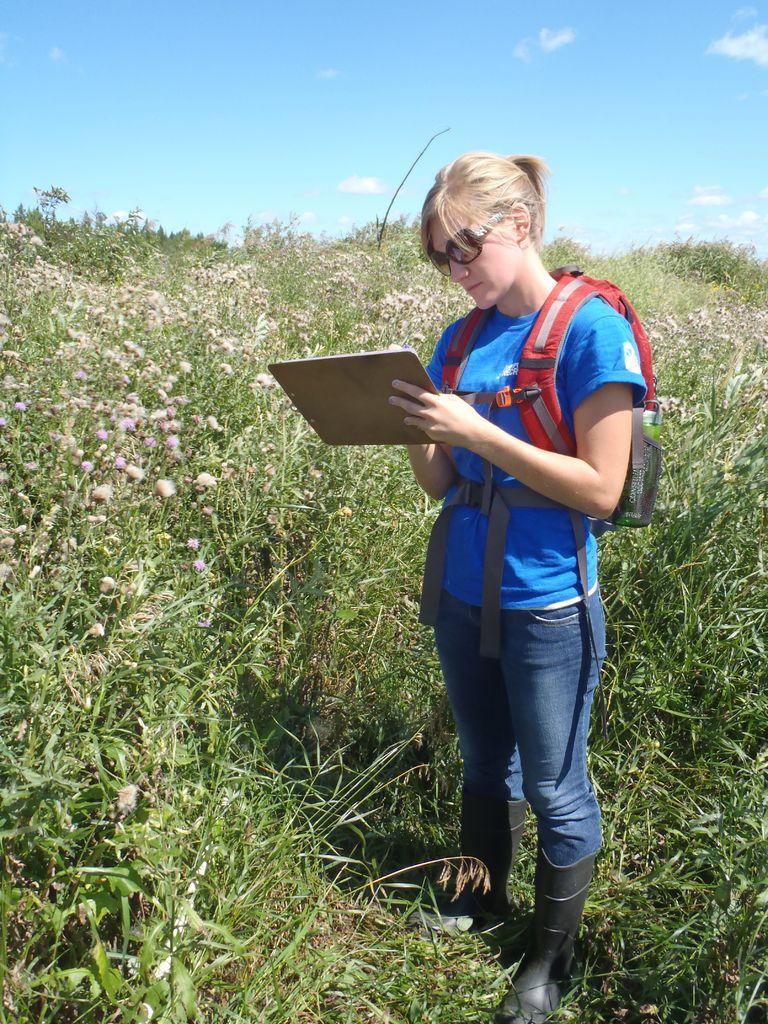What is the woman holding in her hand in the image? The woman is holding a pad, a worn bag, and goggles. What is the woman looking at in the image? The woman is looking at the pad. What can be seen in the background of the image? There are planets, sky, and clouds visible in the background. Can you see any chickens running along the seashore in the image? There is no seashore or chicken present in the image. Is the woman experiencing any pain while holding the items in the image? There is no indication of pain in the image, and we cannot determine the woman's physical state based on the provided facts. 